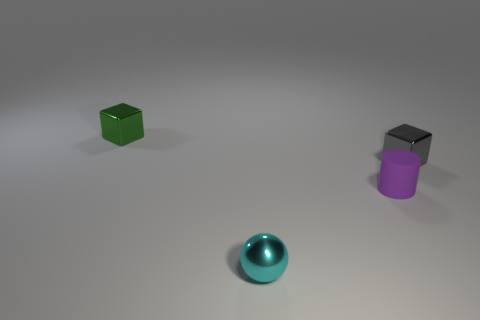Add 3 cyan metal balls. How many objects exist? 7 Add 2 small things. How many small things are left? 6 Add 2 green shiny objects. How many green shiny objects exist? 3 Subtract 1 cyan balls. How many objects are left? 3 Subtract all tiny purple cylinders. Subtract all green metallic blocks. How many objects are left? 2 